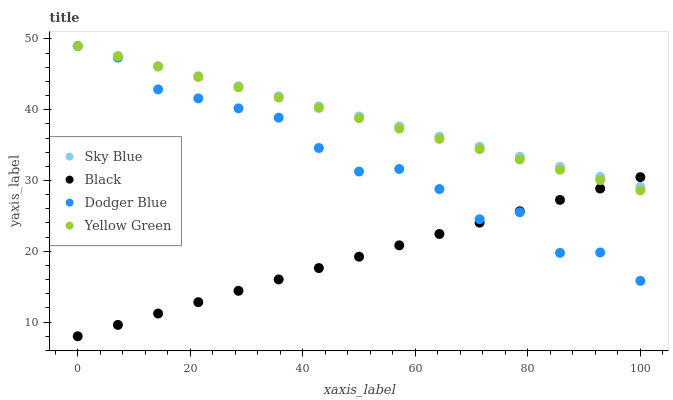Does Black have the minimum area under the curve?
Answer yes or no. Yes. Does Sky Blue have the maximum area under the curve?
Answer yes or no. Yes. Does Yellow Green have the minimum area under the curve?
Answer yes or no. No. Does Yellow Green have the maximum area under the curve?
Answer yes or no. No. Is Black the smoothest?
Answer yes or no. Yes. Is Dodger Blue the roughest?
Answer yes or no. Yes. Is Yellow Green the smoothest?
Answer yes or no. No. Is Yellow Green the roughest?
Answer yes or no. No. Does Black have the lowest value?
Answer yes or no. Yes. Does Yellow Green have the lowest value?
Answer yes or no. No. Does Dodger Blue have the highest value?
Answer yes or no. Yes. Does Black have the highest value?
Answer yes or no. No. Does Dodger Blue intersect Black?
Answer yes or no. Yes. Is Dodger Blue less than Black?
Answer yes or no. No. Is Dodger Blue greater than Black?
Answer yes or no. No. 